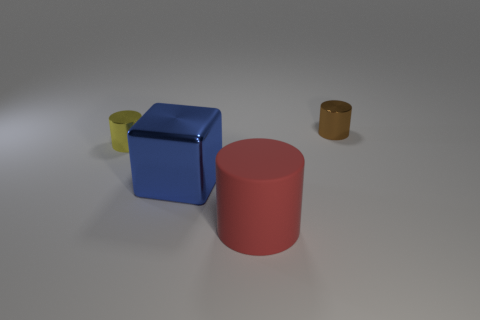Subtract all big red cylinders. How many cylinders are left? 2 Add 4 big rubber things. How many objects exist? 8 Subtract all blue cylinders. Subtract all gray balls. How many cylinders are left? 3 Subtract all blocks. How many objects are left? 3 Add 2 blue shiny blocks. How many blue shiny blocks exist? 3 Subtract 0 green balls. How many objects are left? 4 Subtract all large matte things. Subtract all matte objects. How many objects are left? 2 Add 2 yellow metallic objects. How many yellow metallic objects are left? 3 